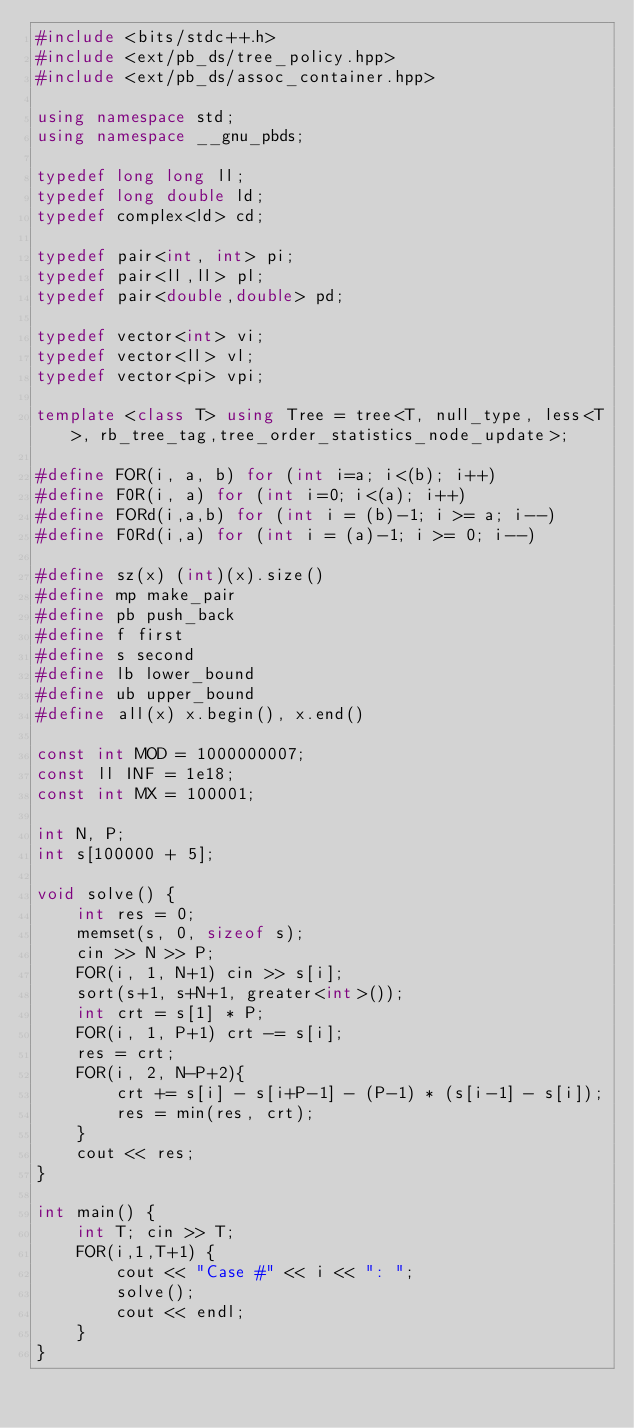Convert code to text. <code><loc_0><loc_0><loc_500><loc_500><_C++_>#include <bits/stdc++.h>
#include <ext/pb_ds/tree_policy.hpp>
#include <ext/pb_ds/assoc_container.hpp>

using namespace std;
using namespace __gnu_pbds;
 
typedef long long ll;
typedef long double ld;
typedef complex<ld> cd;

typedef pair<int, int> pi;
typedef pair<ll,ll> pl;
typedef pair<double,double> pd;

typedef vector<int> vi;
typedef vector<ll> vl;
typedef vector<pi> vpi;

template <class T> using Tree = tree<T, null_type, less<T>, rb_tree_tag,tree_order_statistics_node_update>;

#define FOR(i, a, b) for (int i=a; i<(b); i++)
#define F0R(i, a) for (int i=0; i<(a); i++)
#define FORd(i,a,b) for (int i = (b)-1; i >= a; i--)
#define F0Rd(i,a) for (int i = (a)-1; i >= 0; i--)

#define sz(x) (int)(x).size()
#define mp make_pair
#define pb push_back
#define f first
#define s second
#define lb lower_bound
#define ub upper_bound
#define all(x) x.begin(), x.end()

const int MOD = 1000000007;
const ll INF = 1e18;
const int MX = 100001;

int N, P;
int s[100000 + 5];

void solve() {
    int res = 0;
    memset(s, 0, sizeof s);
    cin >> N >> P;
    FOR(i, 1, N+1) cin >> s[i];
    sort(s+1, s+N+1, greater<int>());
    int crt = s[1] * P;
    FOR(i, 1, P+1) crt -= s[i];
    res = crt;
    FOR(i, 2, N-P+2){
        crt += s[i] - s[i+P-1] - (P-1) * (s[i-1] - s[i]);
        res = min(res, crt);
    }
    cout << res;
}

int main() {
    int T; cin >> T;
    FOR(i,1,T+1) {
        cout << "Case #" << i << ": ";
        solve();
        cout << endl;
    }
}
</code> 